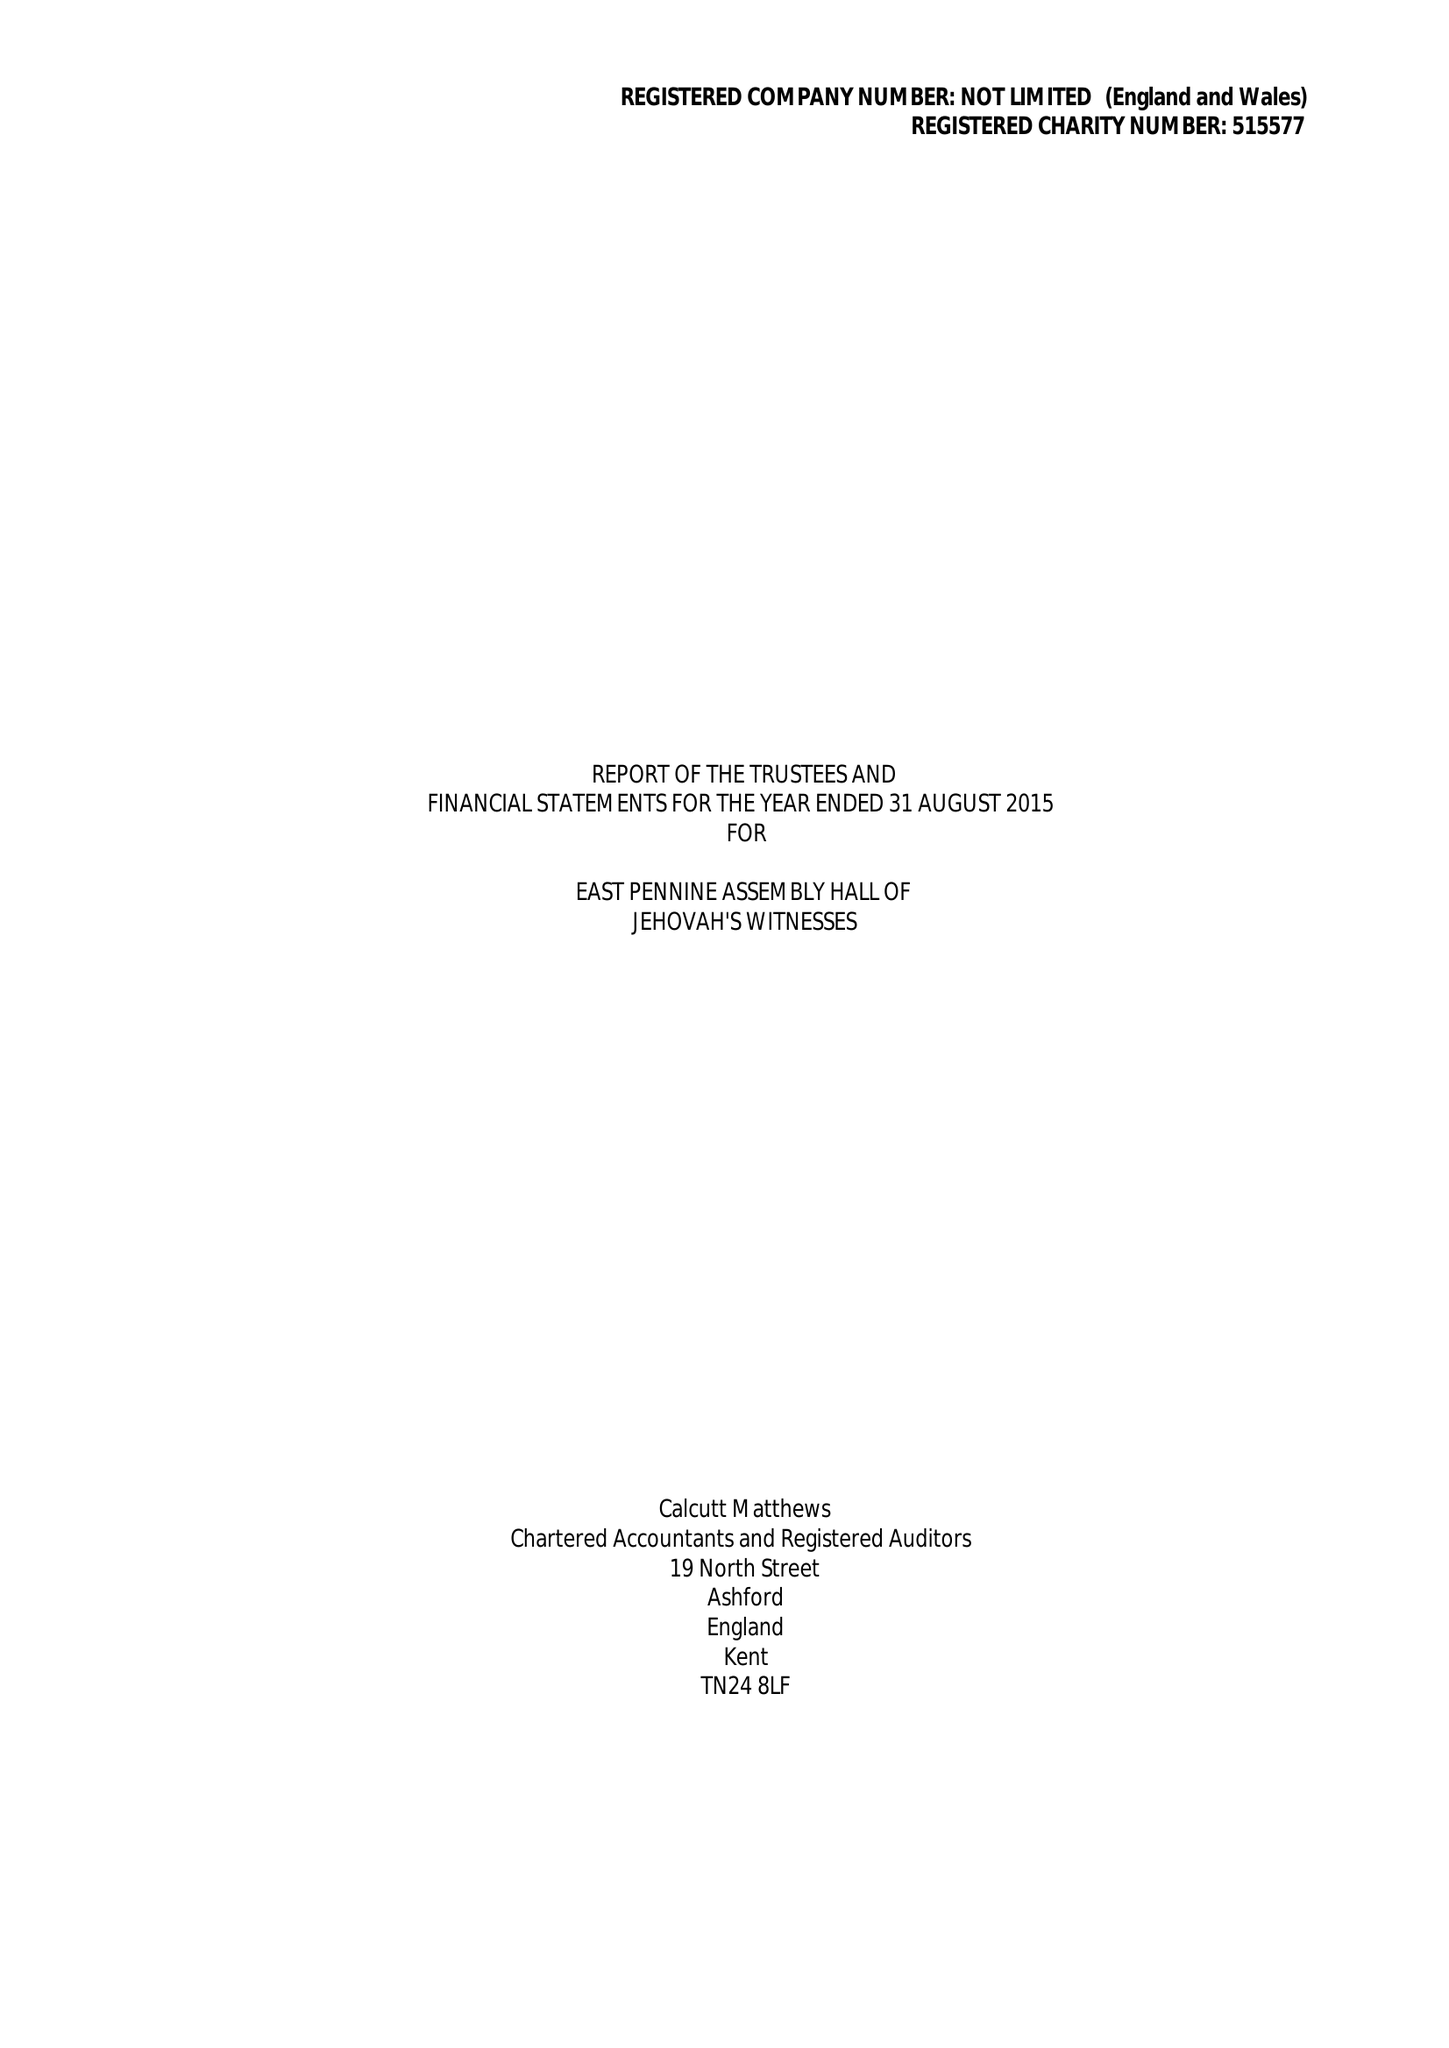What is the value for the charity_name?
Answer the question using a single word or phrase. East Pennine Assembly Hall Of Jehovah's Witnesses 